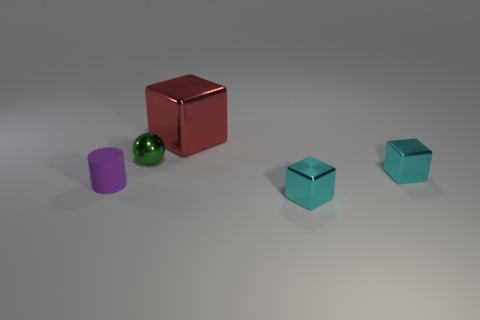What is the shape of the tiny purple matte object?
Your answer should be very brief. Cylinder. There is a small cyan shiny thing behind the rubber cylinder; is it the same shape as the matte thing?
Keep it short and to the point. No. Are there more small shiny spheres that are behind the tiny purple cylinder than purple matte cylinders behind the tiny metallic sphere?
Offer a very short reply. Yes. What number of other things are there of the same size as the red cube?
Provide a succinct answer. 0. There is a small matte object; is it the same shape as the small shiny thing in front of the tiny purple thing?
Your response must be concise. No. How many rubber things are small green spheres or tiny purple things?
Your answer should be compact. 1. Is there another matte cylinder that has the same color as the matte cylinder?
Your answer should be compact. No. Is there a large blue metal object?
Your response must be concise. No. Is the shape of the large red thing the same as the purple thing?
Your response must be concise. No. How many small things are cylinders or metallic things?
Your response must be concise. 4. 